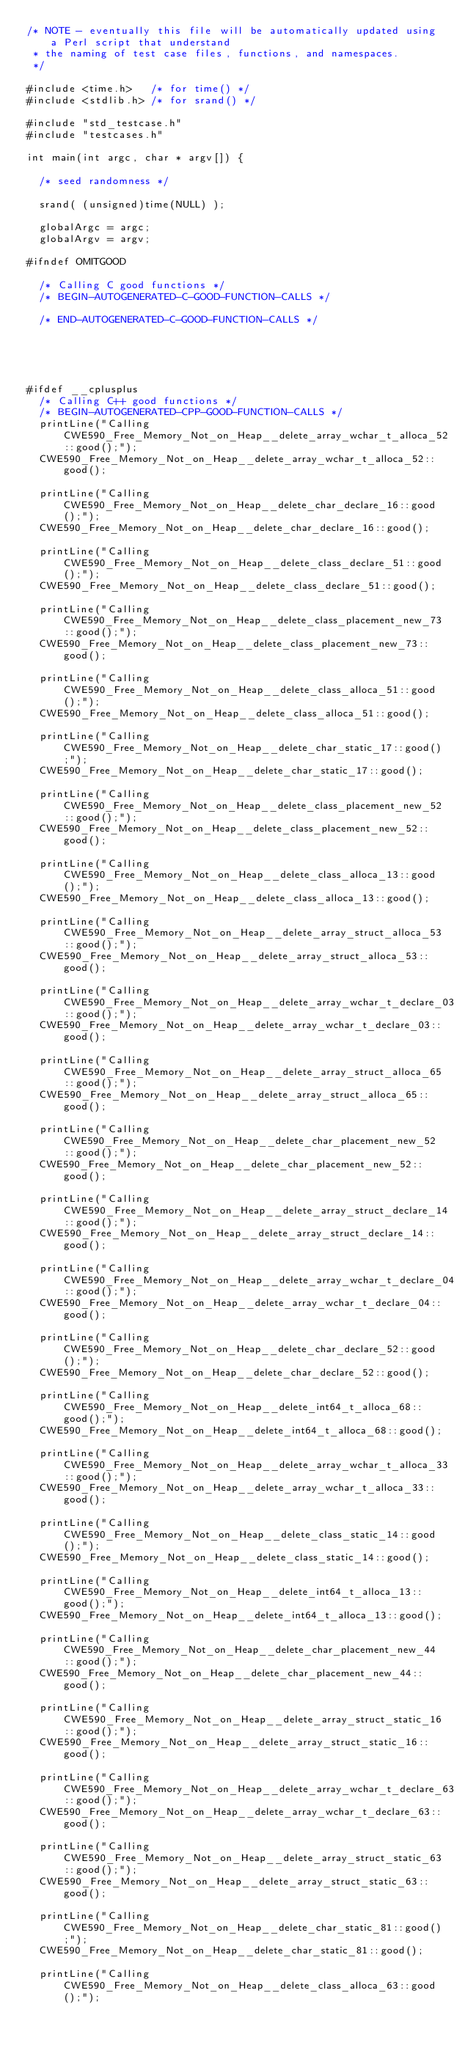<code> <loc_0><loc_0><loc_500><loc_500><_C++_>/* NOTE - eventually this file will be automatically updated using a Perl script that understand
 * the naming of test case files, functions, and namespaces.
 */

#include <time.h>   /* for time() */
#include <stdlib.h> /* for srand() */

#include "std_testcase.h"
#include "testcases.h"

int main(int argc, char * argv[]) {

	/* seed randomness */

	srand( (unsigned)time(NULL) );

	globalArgc = argc;
	globalArgv = argv;

#ifndef OMITGOOD

	/* Calling C good functions */
	/* BEGIN-AUTOGENERATED-C-GOOD-FUNCTION-CALLS */

	/* END-AUTOGENERATED-C-GOOD-FUNCTION-CALLS */





#ifdef __cplusplus
	/* Calling C++ good functions */
	/* BEGIN-AUTOGENERATED-CPP-GOOD-FUNCTION-CALLS */
	printLine("Calling CWE590_Free_Memory_Not_on_Heap__delete_array_wchar_t_alloca_52::good();");
	CWE590_Free_Memory_Not_on_Heap__delete_array_wchar_t_alloca_52::good();

	printLine("Calling CWE590_Free_Memory_Not_on_Heap__delete_char_declare_16::good();");
	CWE590_Free_Memory_Not_on_Heap__delete_char_declare_16::good();

	printLine("Calling CWE590_Free_Memory_Not_on_Heap__delete_class_declare_51::good();");
	CWE590_Free_Memory_Not_on_Heap__delete_class_declare_51::good();

	printLine("Calling CWE590_Free_Memory_Not_on_Heap__delete_class_placement_new_73::good();");
	CWE590_Free_Memory_Not_on_Heap__delete_class_placement_new_73::good();

	printLine("Calling CWE590_Free_Memory_Not_on_Heap__delete_class_alloca_51::good();");
	CWE590_Free_Memory_Not_on_Heap__delete_class_alloca_51::good();

	printLine("Calling CWE590_Free_Memory_Not_on_Heap__delete_char_static_17::good();");
	CWE590_Free_Memory_Not_on_Heap__delete_char_static_17::good();

	printLine("Calling CWE590_Free_Memory_Not_on_Heap__delete_class_placement_new_52::good();");
	CWE590_Free_Memory_Not_on_Heap__delete_class_placement_new_52::good();

	printLine("Calling CWE590_Free_Memory_Not_on_Heap__delete_class_alloca_13::good();");
	CWE590_Free_Memory_Not_on_Heap__delete_class_alloca_13::good();

	printLine("Calling CWE590_Free_Memory_Not_on_Heap__delete_array_struct_alloca_53::good();");
	CWE590_Free_Memory_Not_on_Heap__delete_array_struct_alloca_53::good();

	printLine("Calling CWE590_Free_Memory_Not_on_Heap__delete_array_wchar_t_declare_03::good();");
	CWE590_Free_Memory_Not_on_Heap__delete_array_wchar_t_declare_03::good();

	printLine("Calling CWE590_Free_Memory_Not_on_Heap__delete_array_struct_alloca_65::good();");
	CWE590_Free_Memory_Not_on_Heap__delete_array_struct_alloca_65::good();

	printLine("Calling CWE590_Free_Memory_Not_on_Heap__delete_char_placement_new_52::good();");
	CWE590_Free_Memory_Not_on_Heap__delete_char_placement_new_52::good();

	printLine("Calling CWE590_Free_Memory_Not_on_Heap__delete_array_struct_declare_14::good();");
	CWE590_Free_Memory_Not_on_Heap__delete_array_struct_declare_14::good();

	printLine("Calling CWE590_Free_Memory_Not_on_Heap__delete_array_wchar_t_declare_04::good();");
	CWE590_Free_Memory_Not_on_Heap__delete_array_wchar_t_declare_04::good();

	printLine("Calling CWE590_Free_Memory_Not_on_Heap__delete_char_declare_52::good();");
	CWE590_Free_Memory_Not_on_Heap__delete_char_declare_52::good();

	printLine("Calling CWE590_Free_Memory_Not_on_Heap__delete_int64_t_alloca_68::good();");
	CWE590_Free_Memory_Not_on_Heap__delete_int64_t_alloca_68::good();

	printLine("Calling CWE590_Free_Memory_Not_on_Heap__delete_array_wchar_t_alloca_33::good();");
	CWE590_Free_Memory_Not_on_Heap__delete_array_wchar_t_alloca_33::good();

	printLine("Calling CWE590_Free_Memory_Not_on_Heap__delete_class_static_14::good();");
	CWE590_Free_Memory_Not_on_Heap__delete_class_static_14::good();

	printLine("Calling CWE590_Free_Memory_Not_on_Heap__delete_int64_t_alloca_13::good();");
	CWE590_Free_Memory_Not_on_Heap__delete_int64_t_alloca_13::good();

	printLine("Calling CWE590_Free_Memory_Not_on_Heap__delete_char_placement_new_44::good();");
	CWE590_Free_Memory_Not_on_Heap__delete_char_placement_new_44::good();

	printLine("Calling CWE590_Free_Memory_Not_on_Heap__delete_array_struct_static_16::good();");
	CWE590_Free_Memory_Not_on_Heap__delete_array_struct_static_16::good();

	printLine("Calling CWE590_Free_Memory_Not_on_Heap__delete_array_wchar_t_declare_63::good();");
	CWE590_Free_Memory_Not_on_Heap__delete_array_wchar_t_declare_63::good();

	printLine("Calling CWE590_Free_Memory_Not_on_Heap__delete_array_struct_static_63::good();");
	CWE590_Free_Memory_Not_on_Heap__delete_array_struct_static_63::good();

	printLine("Calling CWE590_Free_Memory_Not_on_Heap__delete_char_static_81::good();");
	CWE590_Free_Memory_Not_on_Heap__delete_char_static_81::good();

	printLine("Calling CWE590_Free_Memory_Not_on_Heap__delete_class_alloca_63::good();");</code> 